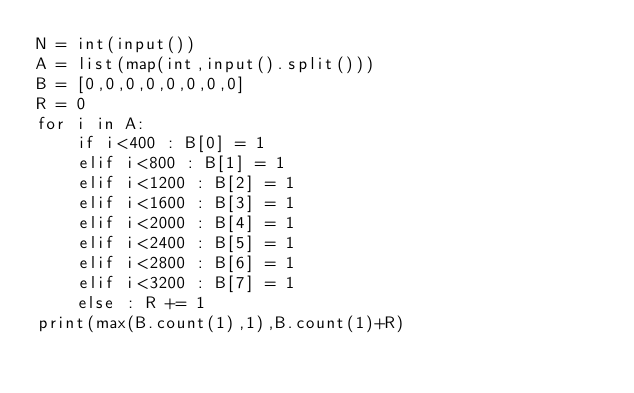<code> <loc_0><loc_0><loc_500><loc_500><_Python_>N = int(input())
A = list(map(int,input().split()))
B = [0,0,0,0,0,0,0,0]
R = 0
for i in A:
    if i<400 : B[0] = 1
    elif i<800 : B[1] = 1
    elif i<1200 : B[2] = 1
    elif i<1600 : B[3] = 1
    elif i<2000 : B[4] = 1
    elif i<2400 : B[5] = 1
    elif i<2800 : B[6] = 1
    elif i<3200 : B[7] = 1
    else : R += 1
print(max(B.count(1),1),B.count(1)+R)
</code> 